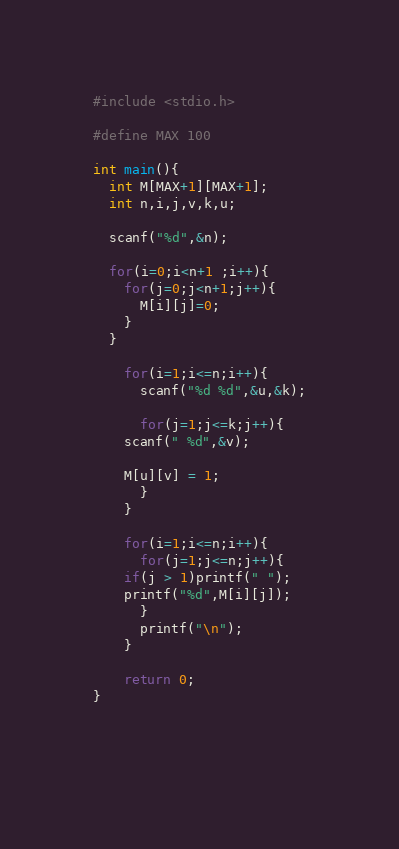Convert code to text. <code><loc_0><loc_0><loc_500><loc_500><_C_>#include <stdio.h>

#define MAX 100

int main(){
  int M[MAX+1][MAX+1];
  int n,i,j,v,k,u;

  scanf("%d",&n);

  for(i=0;i<n+1 ;i++){
    for(j=0;j<n+1;j++){
      M[i][j]=0;
    }
  }

    for(i=1;i<=n;i++){
      scanf("%d %d",&u,&k);

      for(j=1;j<=k;j++){
	scanf(" %d",&v);

	M[u][v] = 1;
      }
    }

    for(i=1;i<=n;i++){
      for(j=1;j<=n;j++){
	if(j > 1)printf(" ");
	printf("%d",M[i][j]);
      }
      printf("\n");
    }

    return 0;
}
    

    

</code> 